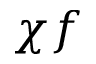Convert formula to latex. <formula><loc_0><loc_0><loc_500><loc_500>\chi f</formula> 